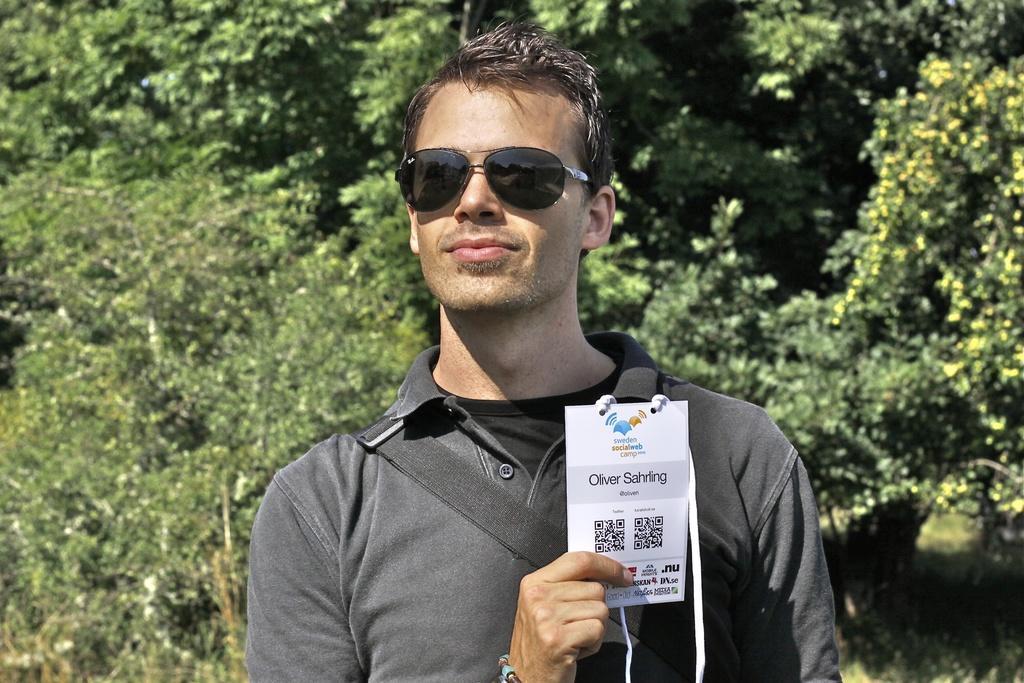Describe this image in one or two sentences. In the center of the image there is a person wearing sunglasses. He is wearing a grey color shirt. He is holding an id card in his hand. At the background of the image there are trees. 